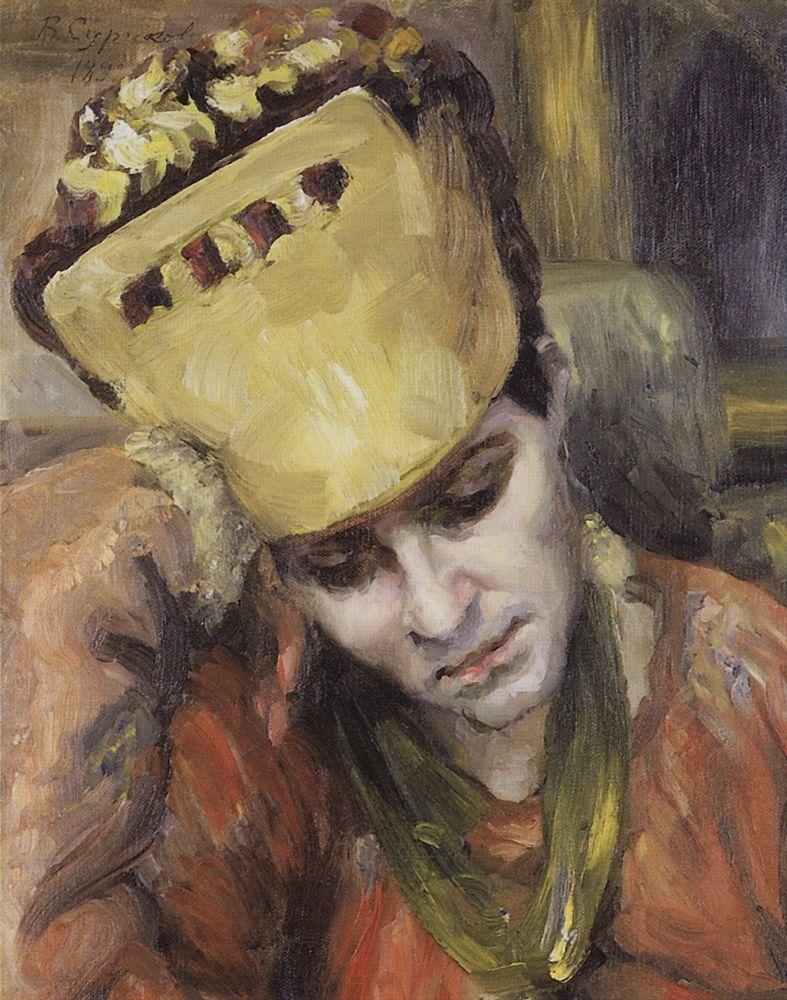Create a whimsical fantasy scenario inspired by this painting. In a quaint and magical village nestled between rolling hills, there lived a young woman named Elara. One day, while wandering through an enchanted forest, she stumbled upon a mysterious yellow hat decorated with glistening flowers. Upon placing the hat on her head, Elara was transported to an ethereal realm where colors danced in the air, and melodies of old whispered secrets of the cosmos. In this realm, she met a wise, ancient tree that revealed she was destined to become the Guardian of Dreams. Every night, Elara would don her hat and journey into the dreams of villagers, mending broken hopes and nurturing the seeds of fantastic adventures. By day, she carried a quiet wisdom, forever touched by the beauty and wonder of the dream world she guarded. 